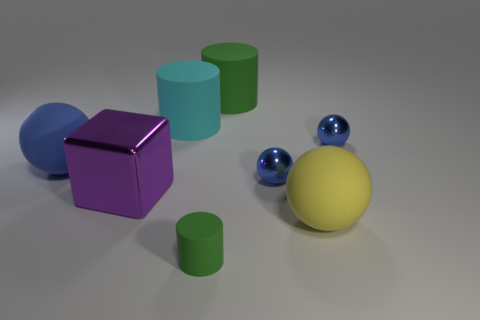Subtract all yellow cylinders. How many blue spheres are left? 3 Subtract all brown spheres. Subtract all red blocks. How many spheres are left? 4 Add 1 large blue matte spheres. How many objects exist? 9 Subtract all cubes. How many objects are left? 7 Subtract all small yellow matte objects. Subtract all tiny balls. How many objects are left? 6 Add 7 big blue spheres. How many big blue spheres are left? 8 Add 4 tiny cylinders. How many tiny cylinders exist? 5 Subtract 1 green cylinders. How many objects are left? 7 